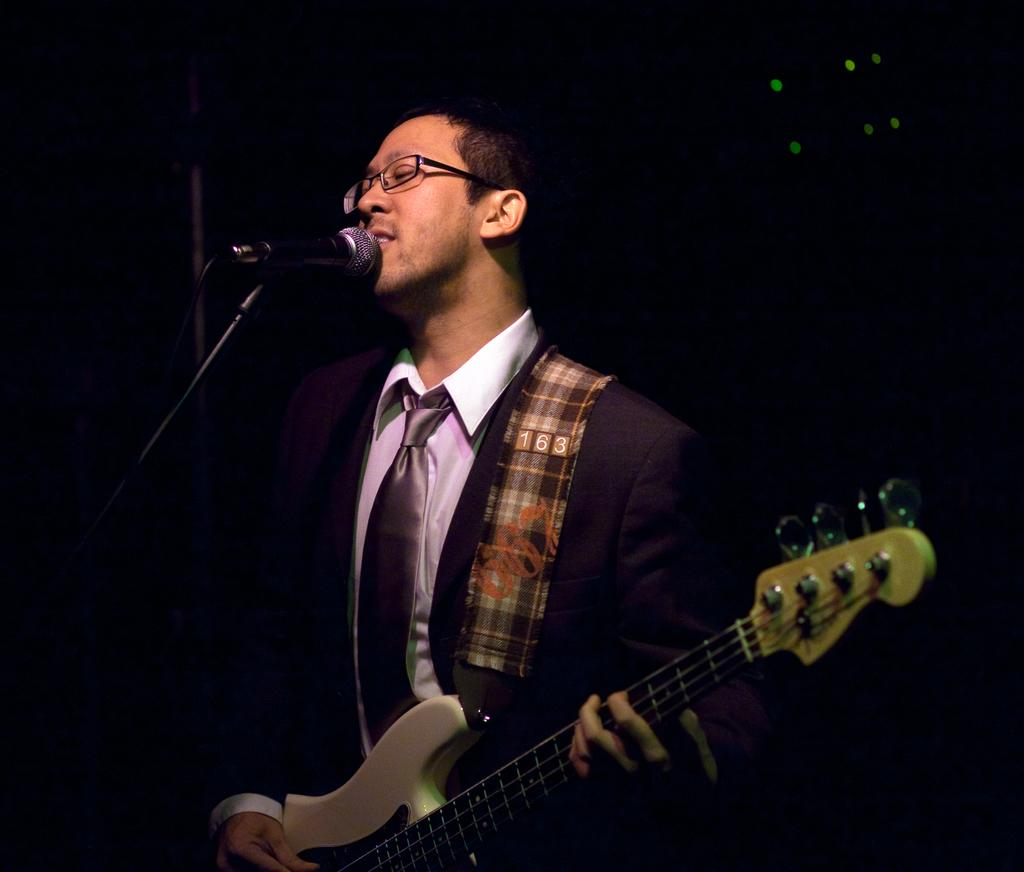What is the main subject of the image? The main subject of the image is a man. What is the man wearing in the image? The man is wearing spectacles in the image. What is the man doing in the image? The man is playing a guitar in the image. How is the guitar being held in the image? The guitar is in the man's hands in the image. What other object can be seen in the image related to the man's activity? There is a microphone in the image. What is the purpose of the stand in the image? The stand is likely used to hold the microphone in the image. What can be observed about the background of the image? The background of the image is dark. Where is the shop located in the image? There is no shop present in the image. 